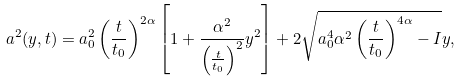<formula> <loc_0><loc_0><loc_500><loc_500>a ^ { 2 } ( y , t ) = a _ { 0 } ^ { 2 } \left ( \frac { t } { t _ { 0 } } \right ) ^ { 2 \alpha } \left [ 1 + \frac { \alpha ^ { 2 } } { \left ( \frac { t } { t _ { 0 } } \right ) ^ { 2 } } y ^ { 2 } \right ] + 2 \sqrt { a _ { 0 } ^ { 4 } \alpha ^ { 2 } \left ( \frac { t } { t _ { 0 } } \right ) ^ { 4 \alpha } - I } y ,</formula> 